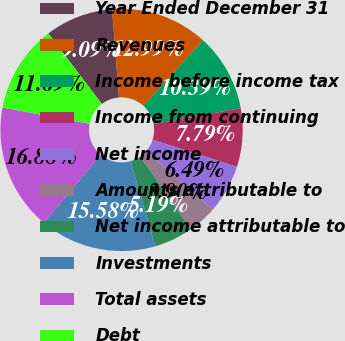Convert chart. <chart><loc_0><loc_0><loc_500><loc_500><pie_chart><fcel>Year Ended December 31<fcel>Revenues<fcel>Income before income tax<fcel>Income from continuing<fcel>Net income<fcel>Amounts attributable to<fcel>Net income attributable to<fcel>Investments<fcel>Total assets<fcel>Debt<nl><fcel>9.09%<fcel>12.99%<fcel>10.39%<fcel>7.79%<fcel>6.49%<fcel>3.9%<fcel>5.19%<fcel>15.58%<fcel>16.88%<fcel>11.69%<nl></chart> 